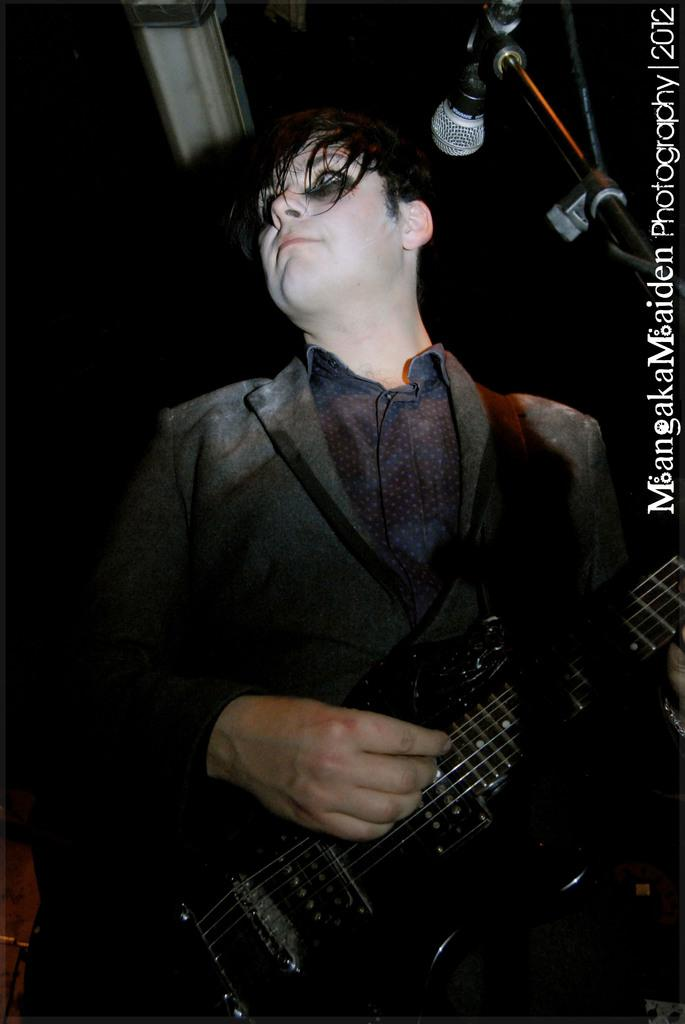Who is the main subject in the image? There is a man in the image. What is the man wearing? The man is wearing a black coat. What is the man doing in the image? The man is playing the guitar. What object is in front of the man? There is a microphone in front of the man. What can be observed about the background of the image? The background of the image is completely dark. Can you see any stars in the image? There are no stars visible in the image, as the background is completely dark. Is there a kitty playing with the guitar in the image? There is no kitty present in the image; it features a man playing the guitar. 